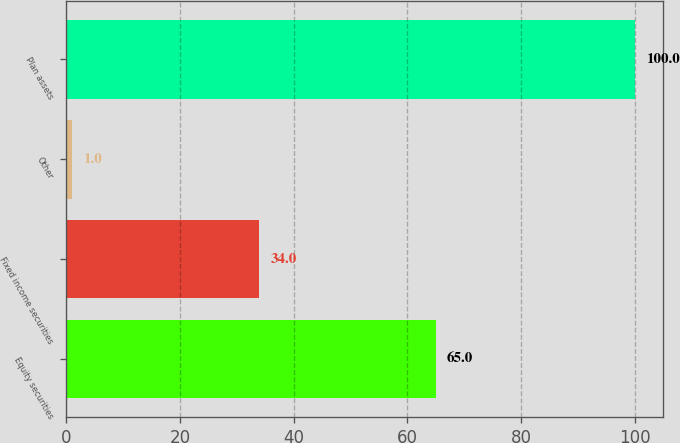<chart> <loc_0><loc_0><loc_500><loc_500><bar_chart><fcel>Equity securities<fcel>Fixed income securities<fcel>Other<fcel>Plan assets<nl><fcel>65<fcel>34<fcel>1<fcel>100<nl></chart> 